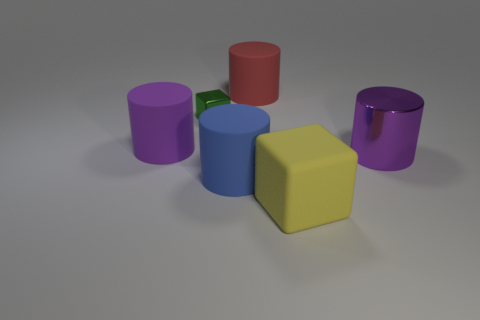How many purple cylinders must be subtracted to get 1 purple cylinders? 1 Subtract 0 red spheres. How many objects are left? 6 Subtract all cylinders. How many objects are left? 2 Subtract 2 cylinders. How many cylinders are left? 2 Subtract all gray cubes. Subtract all brown cylinders. How many cubes are left? 2 Subtract all green cylinders. How many green cubes are left? 1 Subtract all large cylinders. Subtract all tiny red spheres. How many objects are left? 2 Add 1 green cubes. How many green cubes are left? 2 Add 3 small cyan metallic objects. How many small cyan metallic objects exist? 3 Add 1 big yellow metal things. How many objects exist? 7 